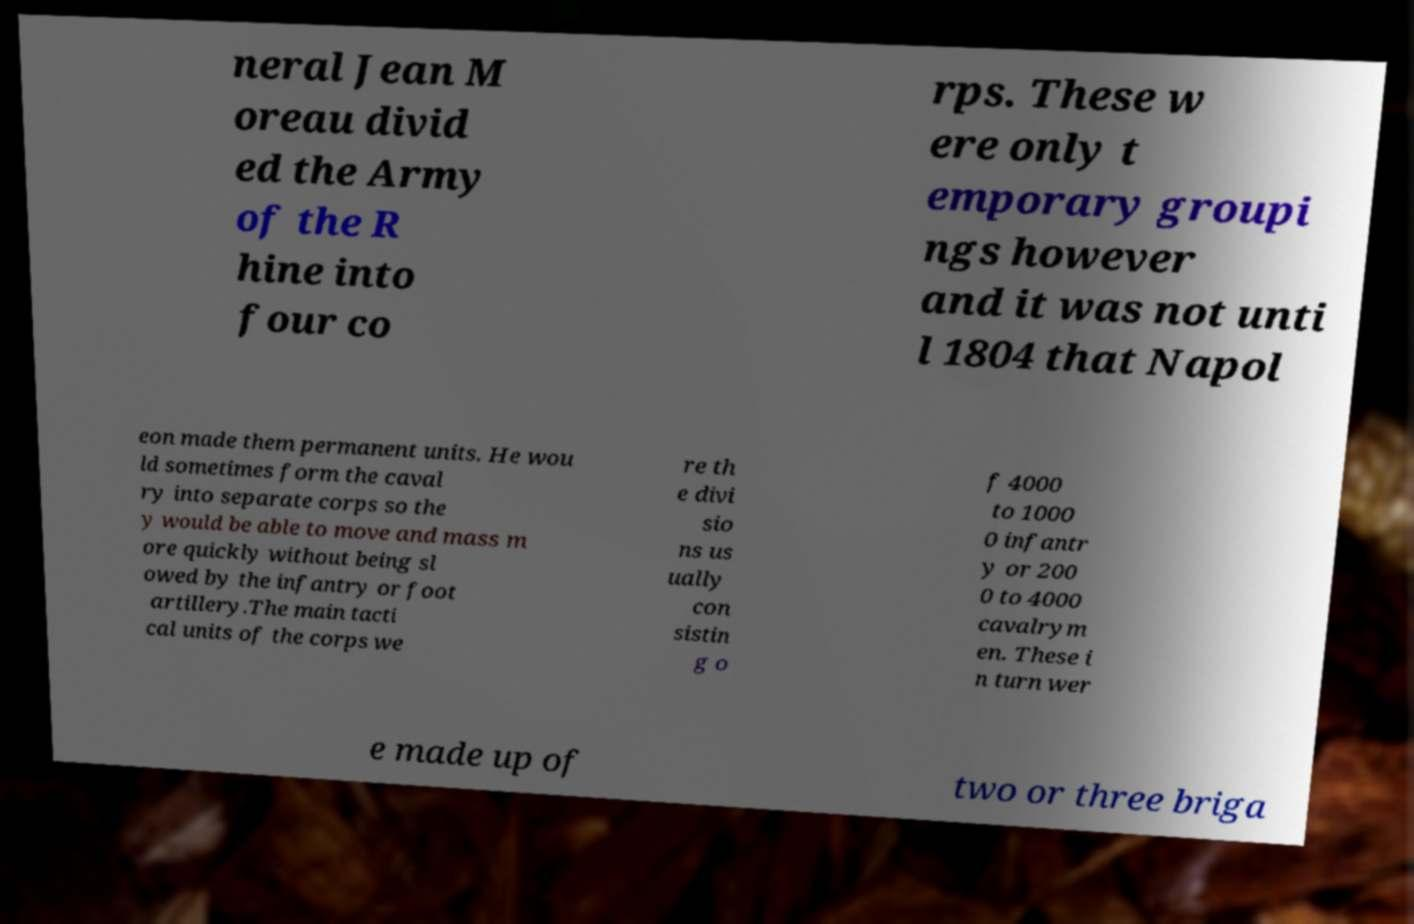Please read and relay the text visible in this image. What does it say? neral Jean M oreau divid ed the Army of the R hine into four co rps. These w ere only t emporary groupi ngs however and it was not unti l 1804 that Napol eon made them permanent units. He wou ld sometimes form the caval ry into separate corps so the y would be able to move and mass m ore quickly without being sl owed by the infantry or foot artillery.The main tacti cal units of the corps we re th e divi sio ns us ually con sistin g o f 4000 to 1000 0 infantr y or 200 0 to 4000 cavalrym en. These i n turn wer e made up of two or three briga 